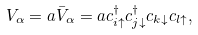<formula> <loc_0><loc_0><loc_500><loc_500>V _ { \alpha } = a \bar { V } _ { \alpha } = a c ^ { \dagger } _ { i \uparrow } c ^ { \dagger } _ { j \downarrow } c _ { k \downarrow } c _ { l \uparrow } ,</formula> 